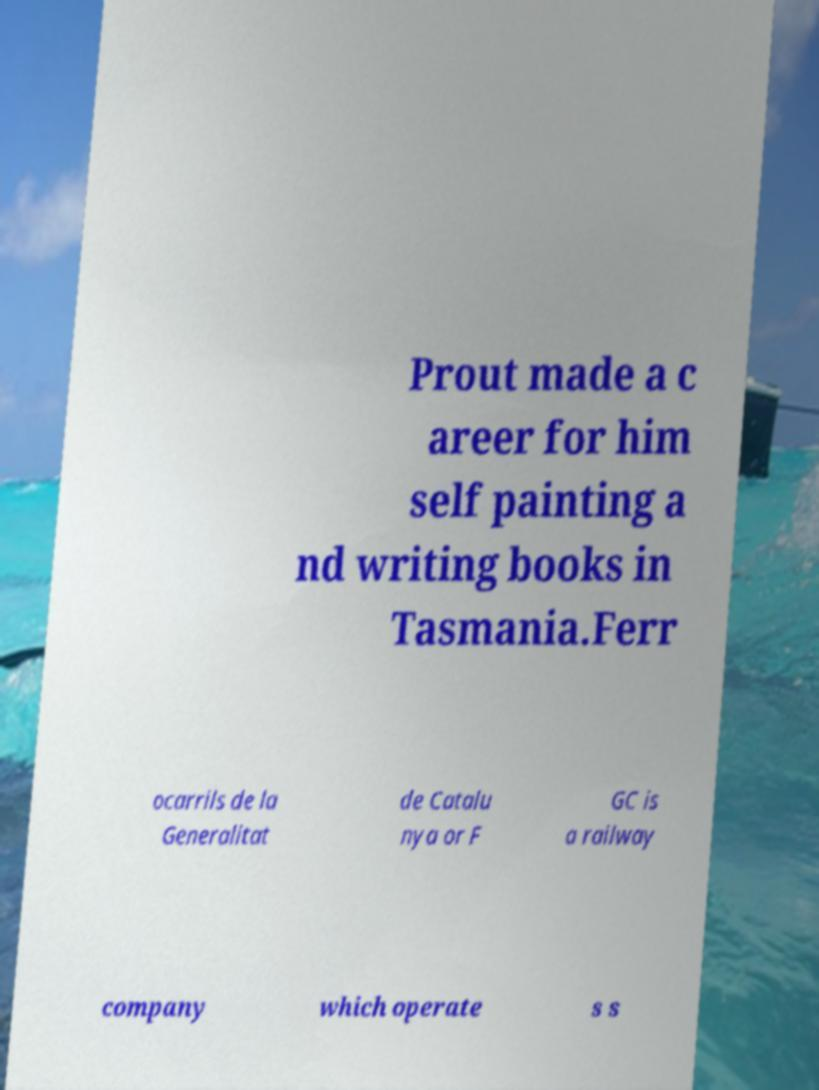Can you read and provide the text displayed in the image?This photo seems to have some interesting text. Can you extract and type it out for me? Prout made a c areer for him self painting a nd writing books in Tasmania.Ferr ocarrils de la Generalitat de Catalu nya or F GC is a railway company which operate s s 